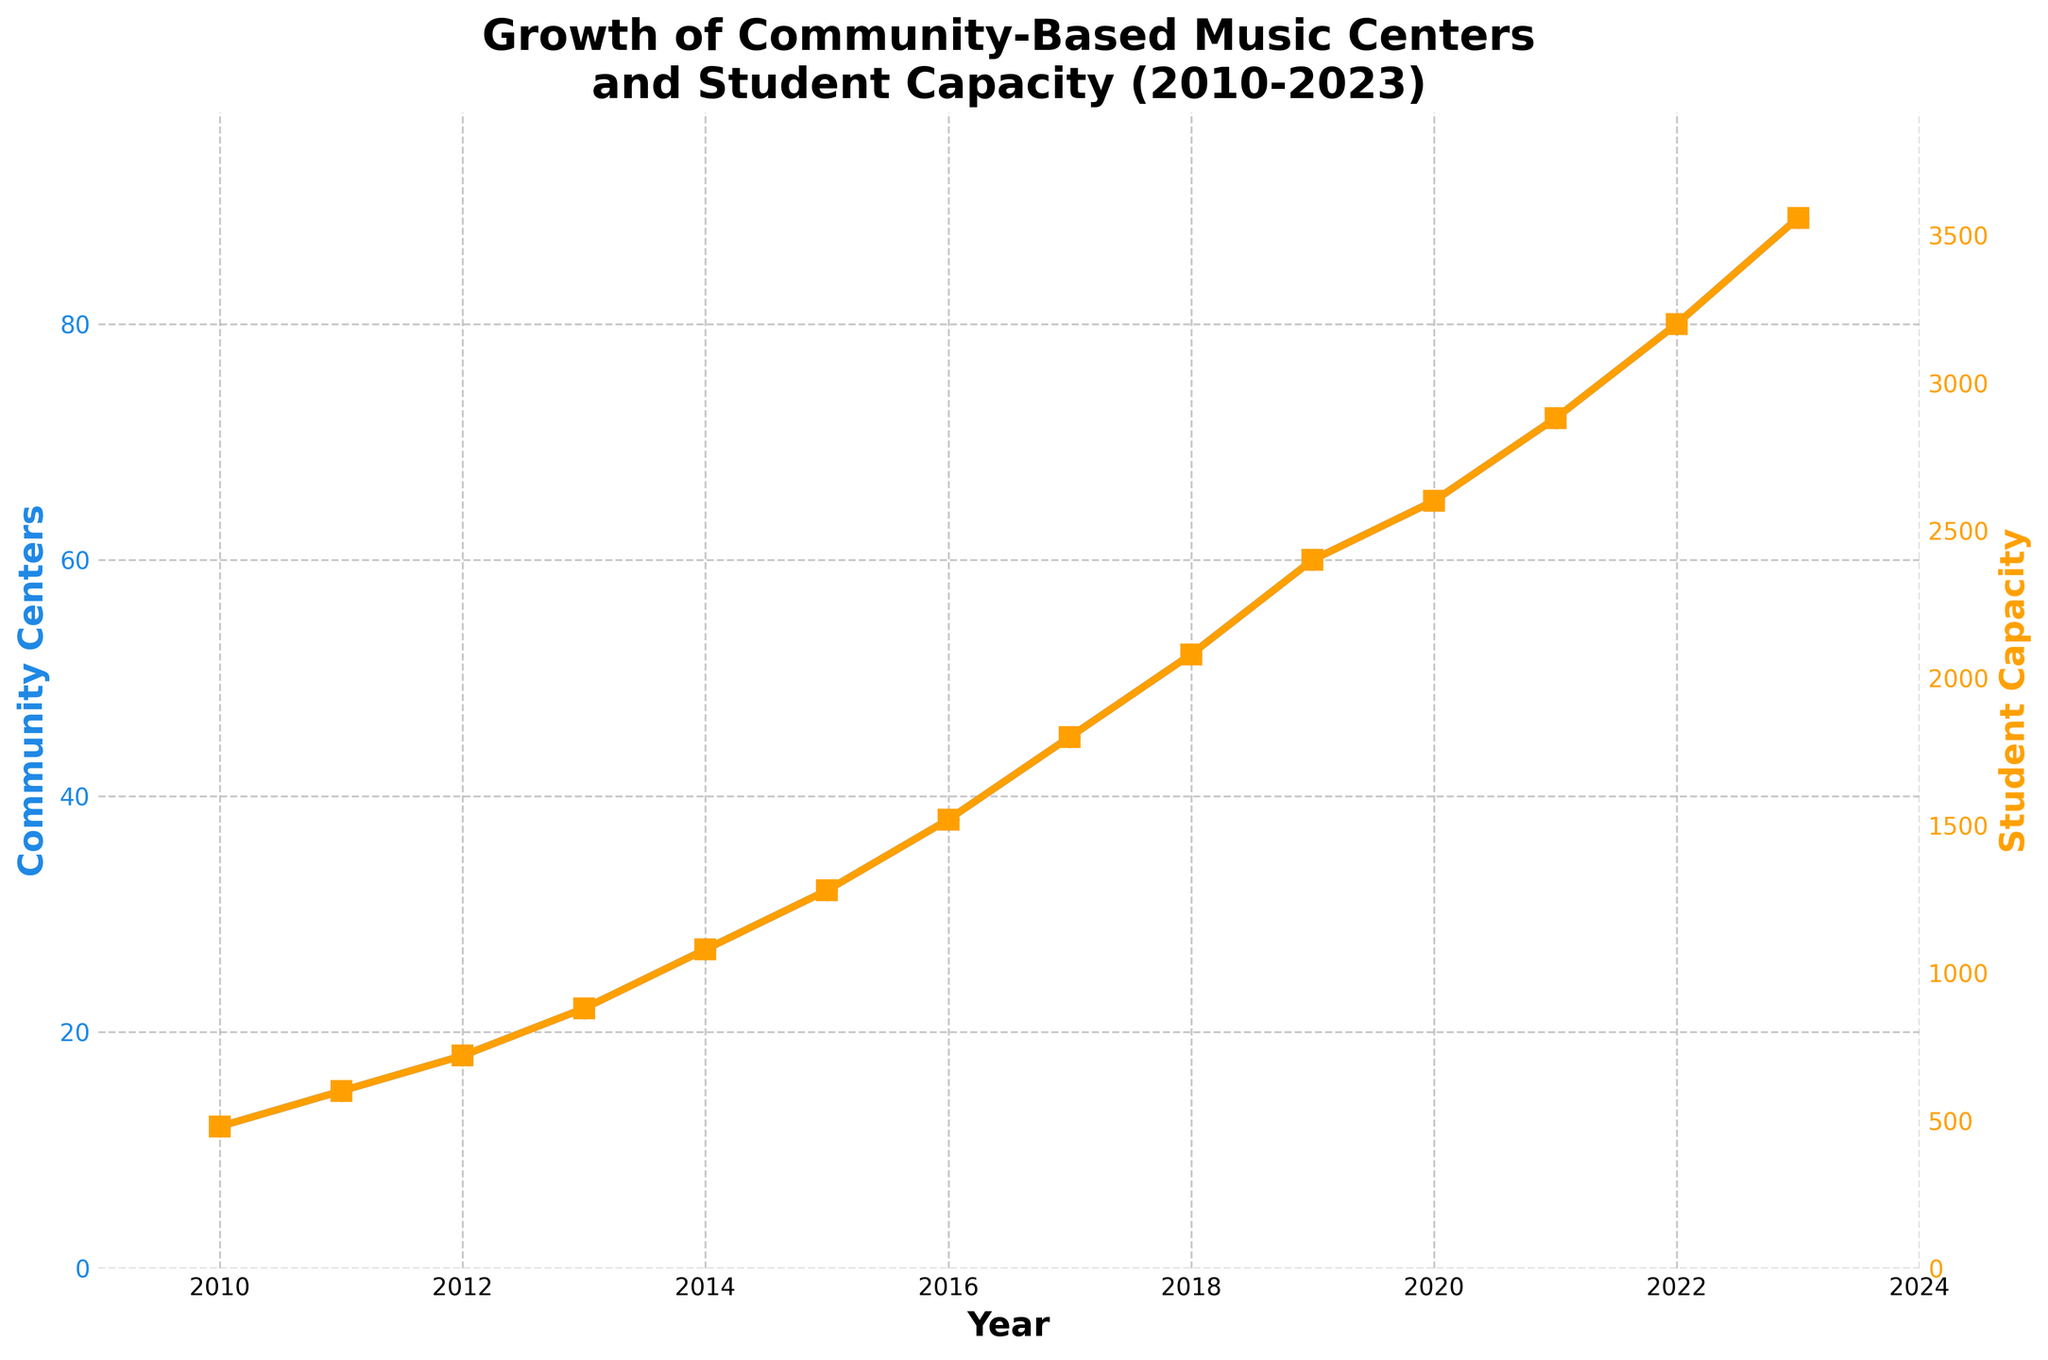What's the trend in the number of community centers from 2010 to 2023? The line representing the number of community centers shows an upward trend from 2010 to 2023, starting at 12 in 2010 and increasing to 89 in 2023.
Answer: Upward trend How has the student capacity changed from 2010 to 2023? The student capacity line shows a gradual increase from 480 in 2010 to 3560 in 2023. This reflects a consistent growth.
Answer: Increased In which year did the number of community centers exceed 50 for the first time? Looking at the plot for community centers, the first year the count exceeds 50 is 2018.
Answer: 2018 What was the approximate student capacity in 2015? The student capacity in 2015 can be found by locating the data point for 2015 on the second y-axis, which is around 1280 students.
Answer: 1280 What is the difference in the number of community centers between 2011 and 2016? The number of community centers in 2011 is 15 and in 2016 it is 38. The difference is 38 - 15.
Answer: 23 Compare the growth rate of student capacity between 2010-2015 and 2015-2020. Between 2010 and 2015, the student capacity increased from 480 to 1280, which is a difference of 800. From 2015 to 2020, it increased from 1280 to 2600, which is a difference of 1320. The later period shows a higher growth rate (1320 vs. 800).
Answer: Higher in 2015-2020 What can you say about the relative growth of the student capacity compared to the number of community centers from 2010 to 2023? Both metrics show considerable growth, but the student capacity increases at a rate proportional to the number of community centers. The relationship appears consistent and linear, indicating synchronized expansion.
Answer: Proportional growth What is the average number of community centers added per year from 2010 to 2023? Calculate the total increase in community centers from 2010 (12 centers) to 2023 (89 centers), which is 89 - 12 = 77. Divide this by the number of years (2023 - 2010 = 13). 77/13 ≈ 5.92.
Answer: 5.92 When did the student capacity surpass 2000 for the first time? By checking the plot for the student capacity, this point was first surpassed in 2018.
Answer: 2018 